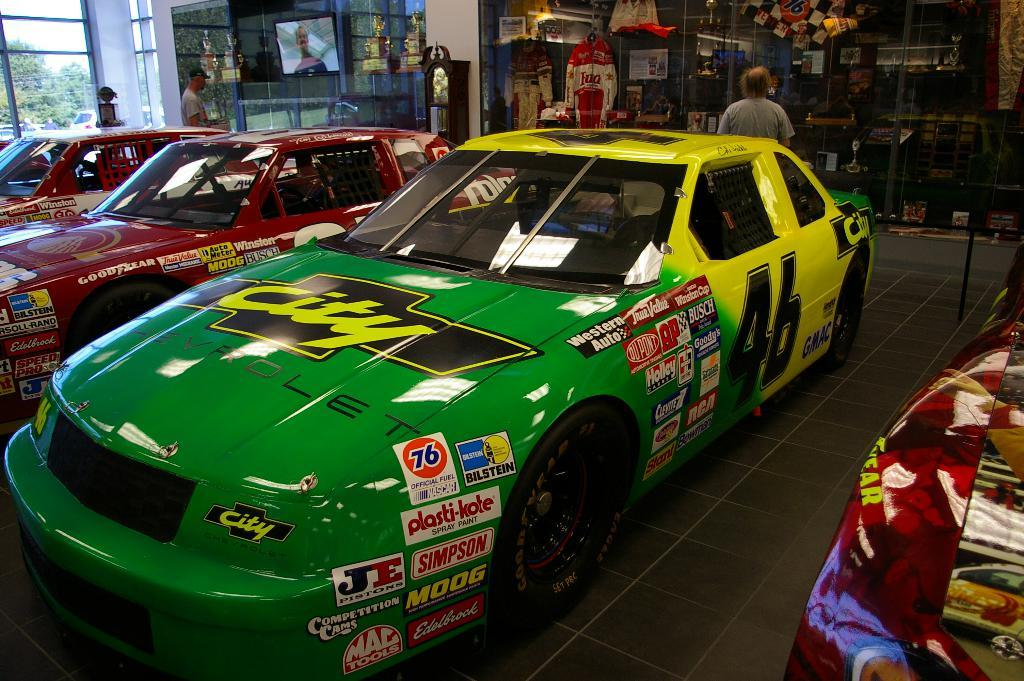<image>
Describe the image concisely. A room full of racecars, with the green number 46 car in the foreground. 